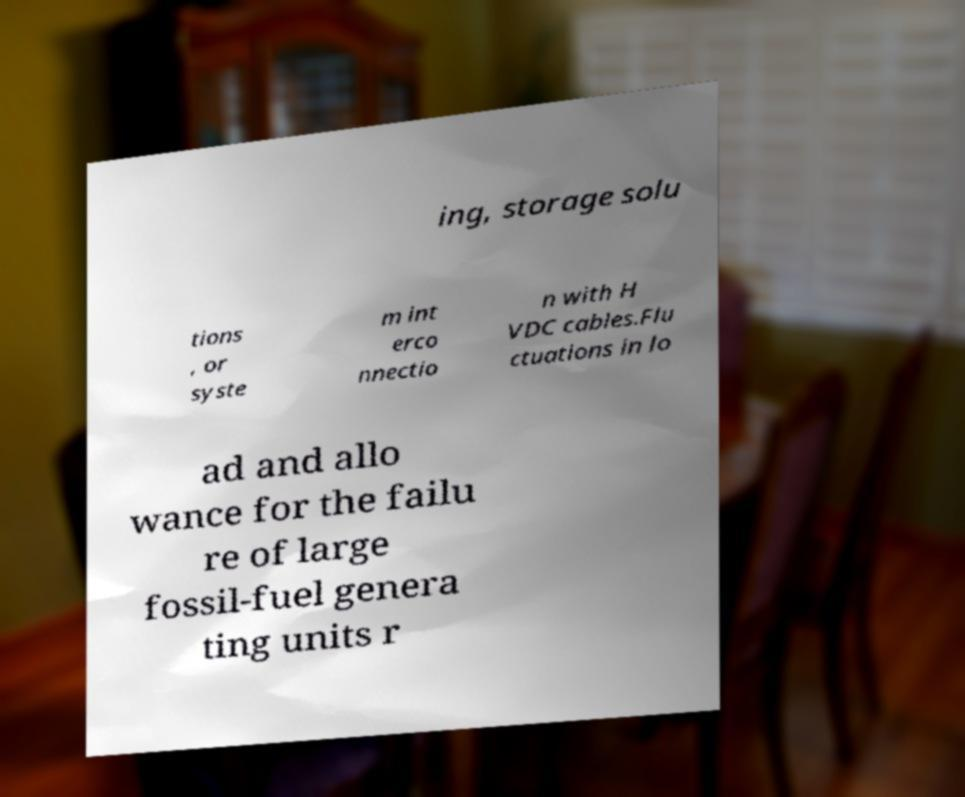There's text embedded in this image that I need extracted. Can you transcribe it verbatim? ing, storage solu tions , or syste m int erco nnectio n with H VDC cables.Flu ctuations in lo ad and allo wance for the failu re of large fossil-fuel genera ting units r 